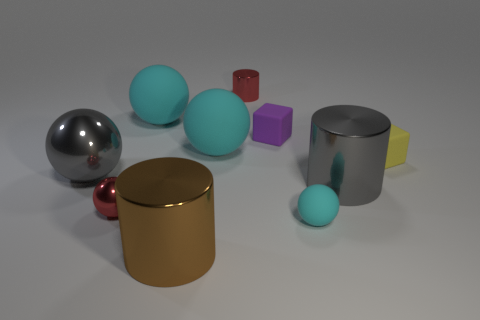Subtract all purple cylinders. How many cyan spheres are left? 3 Subtract all gray balls. How many balls are left? 4 Subtract all tiny red spheres. How many spheres are left? 4 Subtract 1 spheres. How many spheres are left? 4 Subtract all red balls. Subtract all blue cylinders. How many balls are left? 4 Subtract all cylinders. How many objects are left? 7 Subtract all tiny things. Subtract all brown objects. How many objects are left? 4 Add 4 yellow rubber cubes. How many yellow rubber cubes are left? 5 Add 6 tiny purple rubber spheres. How many tiny purple rubber spheres exist? 6 Subtract 1 gray cylinders. How many objects are left? 9 